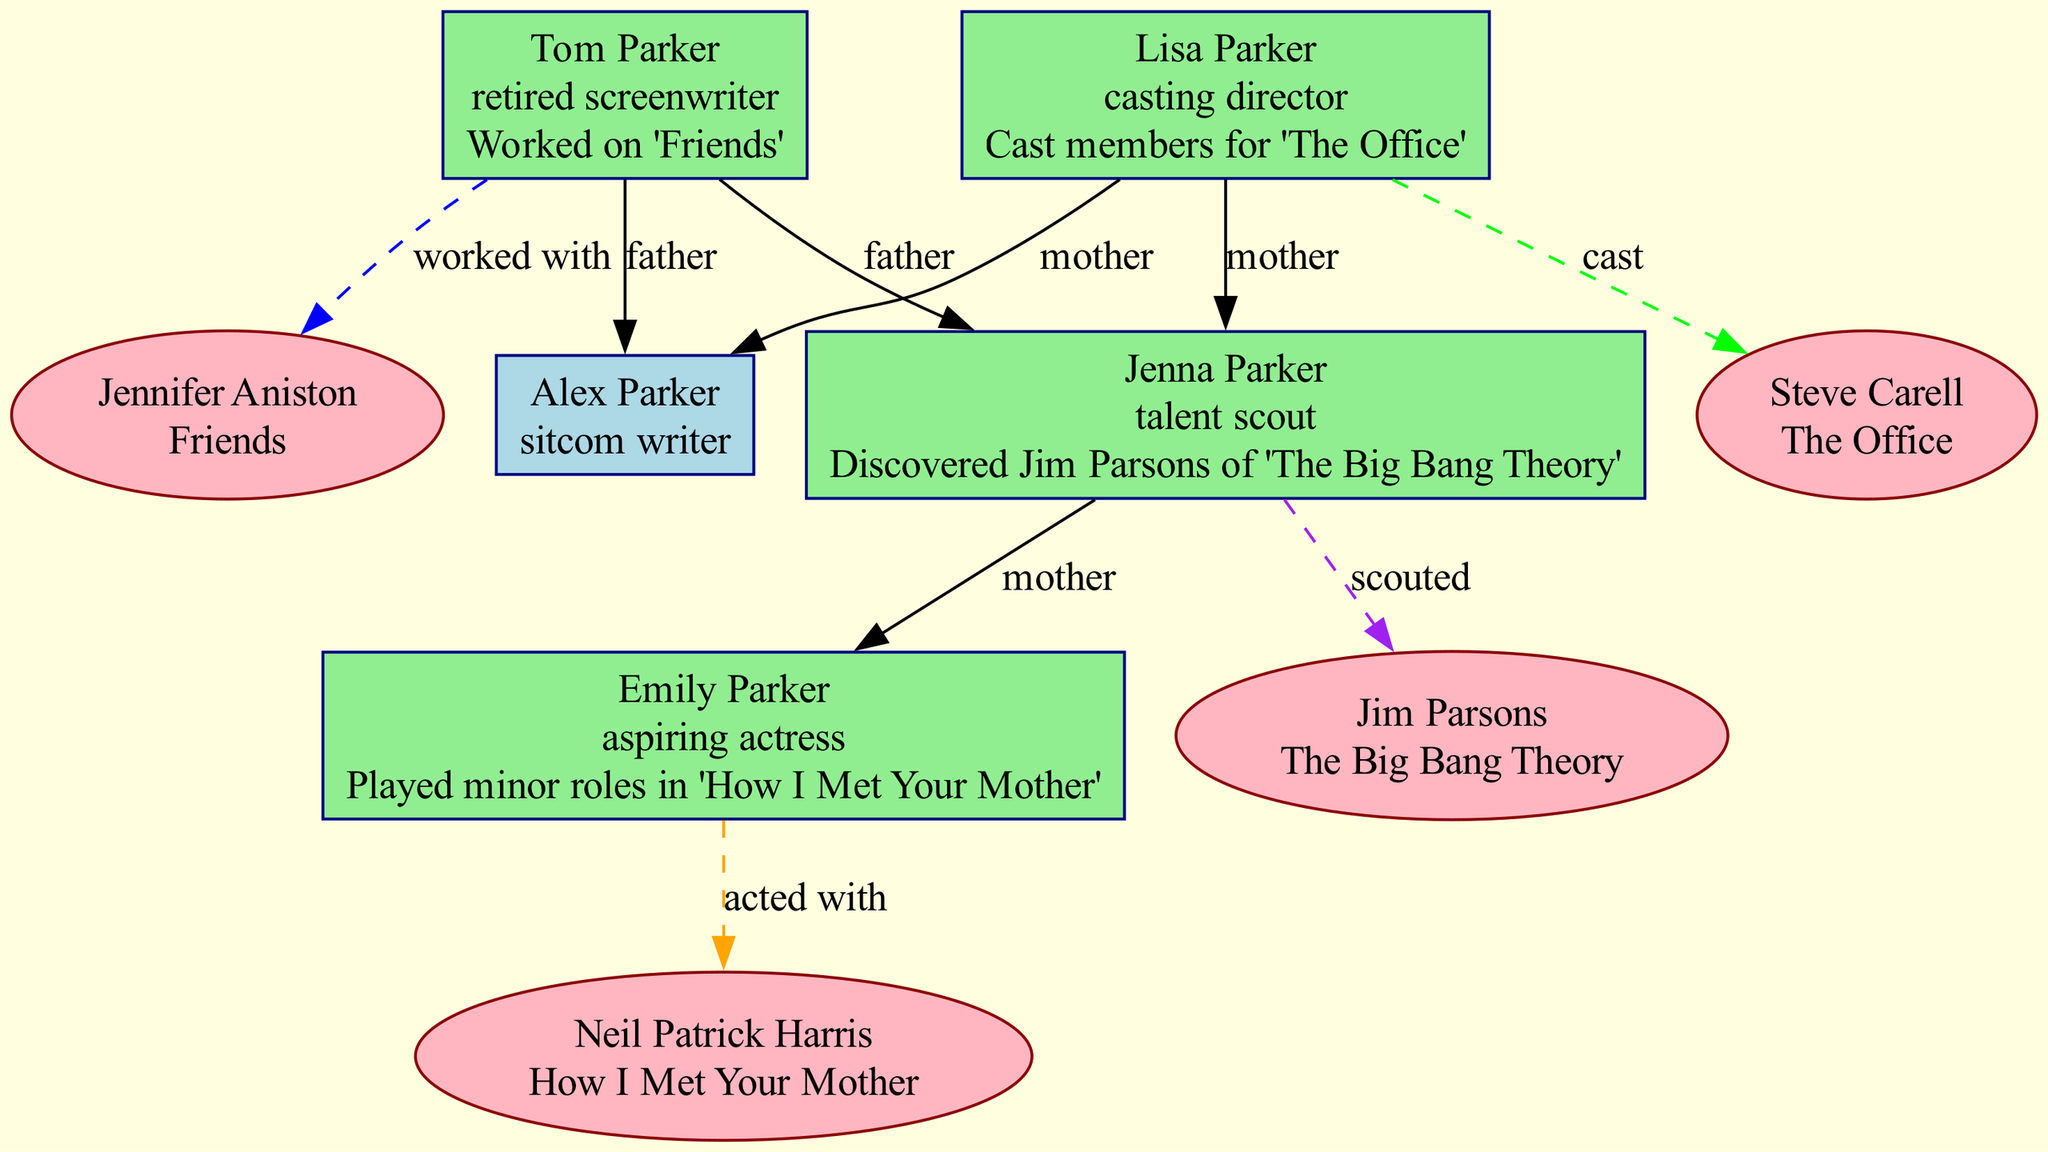What is the profession of Alex Parker? The diagram shows the profession listed next to Alex Parker, which states that he is a "sitcom writer."
Answer: sitcom writer Which sitcom did Tom Parker work on? The diagram indicates that Tom Parker has a connection to sitcoms through his work on "Friends."
Answer: Friends How is Emily Parker related to Jenna Parker? By examining the family relations, Jenna Parker is listed as the mother of Emily Parker.
Answer: mother Who scouted Jim Parsons? The diagram identifies Jenna Parker as the person who discovered Jim Parsons, which is indicated by the connection labeled "scouted."
Answer: Jenna Parker What is the notable role of Emily Parker? The information in the diagram describes that Emily Parker played minor roles in "How I Met Your Mother."
Answer: Played minor roles in 'How I Met Your Mother' How many edges are connected to Lisa Parker? Counting the lines extending from Lisa Parker in the diagram, there are 3 edges connected to her.
Answer: 3 Which sitcom is associated with Steve Carell? The diagram connects Steve Carell with "The Office," which is displayed next to his name in the corresponding node.
Answer: The Office What is the relationship between Tom Parker and Alex Parker? The diagram clearly defines the relationship by indicating that Tom Parker is the father of Alex Parker.
Answer: father Which profession appears twice in the diagram? Analyzing the professions listed, both Tom Parker and Lisa Parker have connections to sitcoms with their respective roles, making "casting director" the repeated profession.
Answer: casting director 